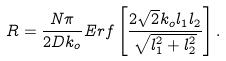<formula> <loc_0><loc_0><loc_500><loc_500>R = \frac { N \pi } { 2 D k _ { o } } E r f \left [ \frac { 2 \sqrt { 2 } k _ { o } l _ { 1 } l _ { 2 } } { \sqrt { l _ { 1 } ^ { 2 } + l _ { 2 } ^ { 2 } } } \right ] .</formula> 